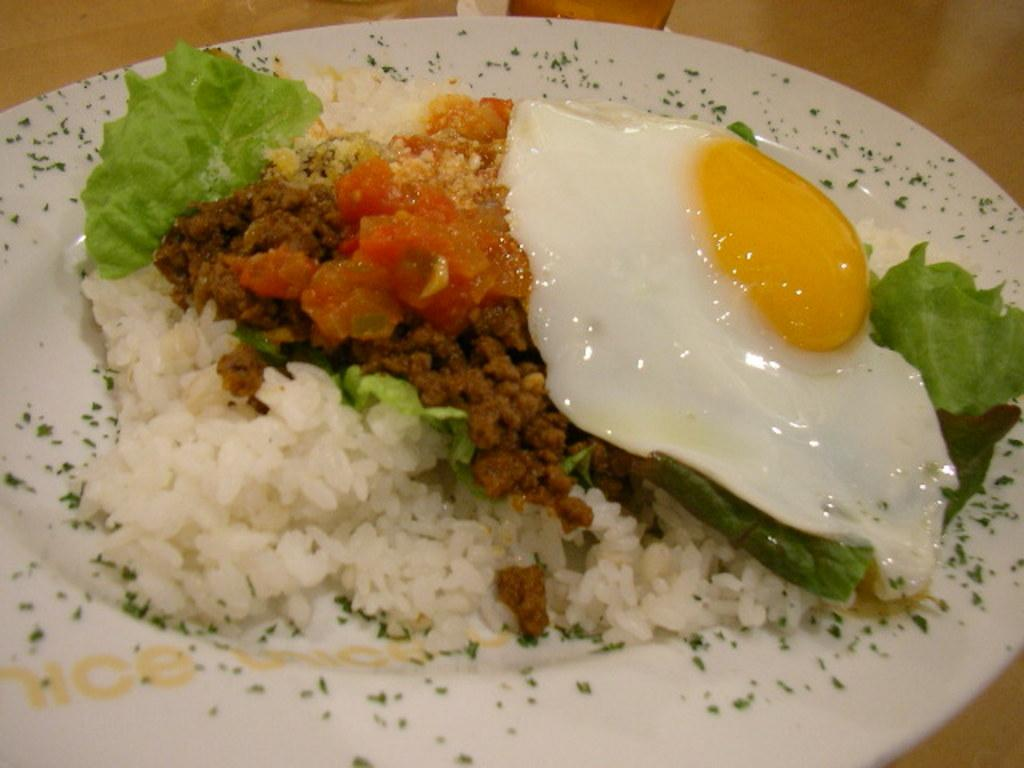What is on the plate that is visible in the image? The plate contains rice, omelette, and fried vegetables. Where is the plate located in the image? The plate is placed on a table. What can be seen in the top right corner of the image? There is a white area in the top right corner of the image. What is the value of the wax in the image? There is no wax present in the image, so it is not possible to determine its value. 